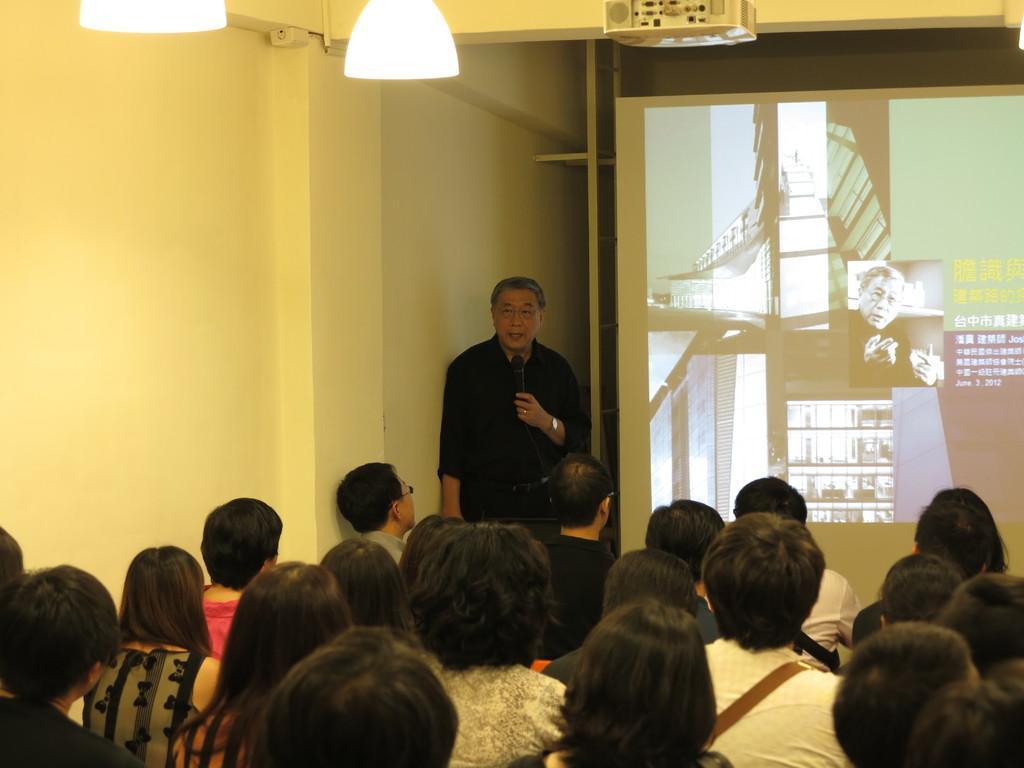How would you summarize this image in a sentence or two? In this picture we can see some people are sitting on the chairs, in front we can see projector screen and one person is standing and holding mike. 